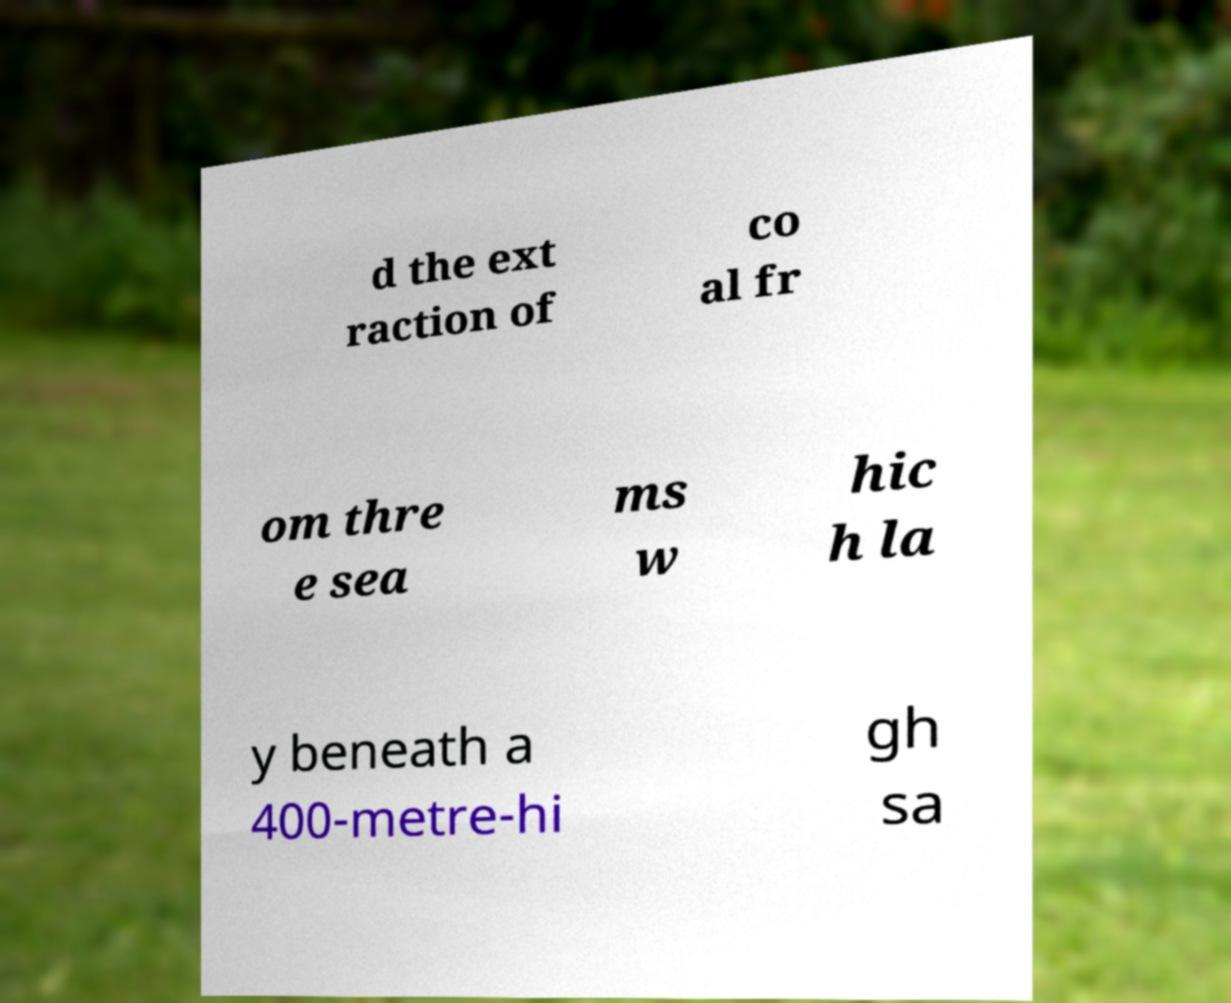Could you assist in decoding the text presented in this image and type it out clearly? d the ext raction of co al fr om thre e sea ms w hic h la y beneath a 400-metre-hi gh sa 